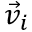<formula> <loc_0><loc_0><loc_500><loc_500>\vec { v } _ { i }</formula> 